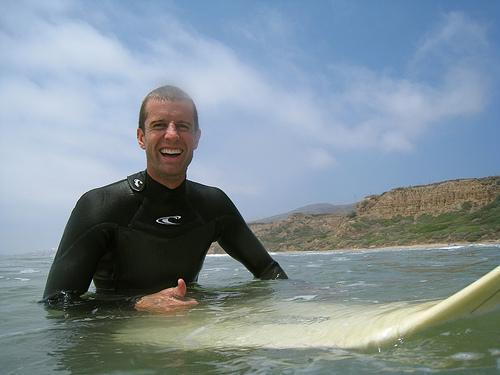How many people are shown?
Give a very brief answer. 1. How many of the person's hands are visible?
Give a very brief answer. 1. How many surfboards are shown?
Give a very brief answer. 1. 